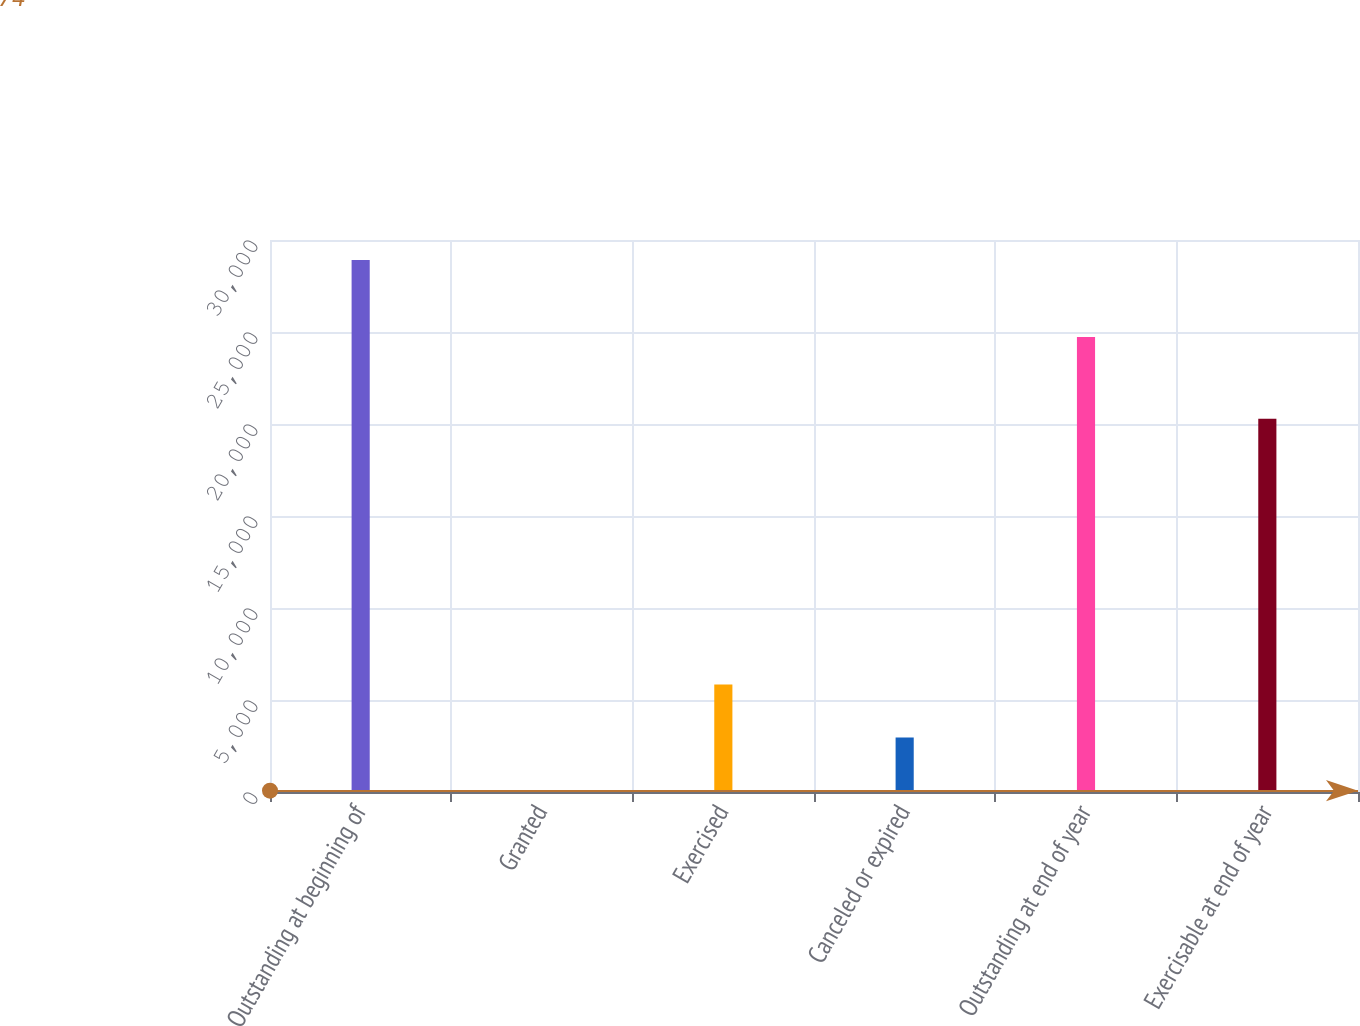Convert chart to OTSL. <chart><loc_0><loc_0><loc_500><loc_500><bar_chart><fcel>Outstanding at beginning of<fcel>Granted<fcel>Exercised<fcel>Canceled or expired<fcel>Outstanding at end of year<fcel>Exercisable at end of year<nl><fcel>28918<fcel>74<fcel>5842.8<fcel>2958.4<fcel>24727<fcel>20290<nl></chart> 